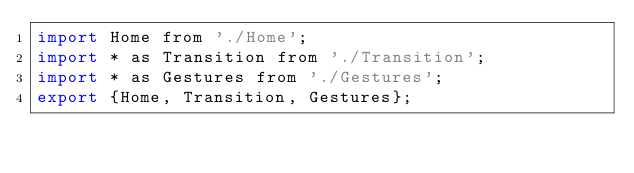Convert code to text. <code><loc_0><loc_0><loc_500><loc_500><_JavaScript_>import Home from './Home';
import * as Transition from './Transition';
import * as Gestures from './Gestures';
export {Home, Transition, Gestures};
</code> 